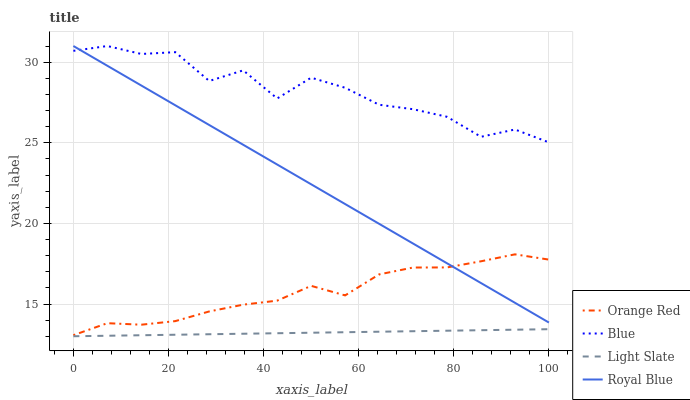Does Orange Red have the minimum area under the curve?
Answer yes or no. No. Does Orange Red have the maximum area under the curve?
Answer yes or no. No. Is Orange Red the smoothest?
Answer yes or no. No. Is Orange Red the roughest?
Answer yes or no. No. Does Orange Red have the lowest value?
Answer yes or no. No. Does Orange Red have the highest value?
Answer yes or no. No. Is Light Slate less than Blue?
Answer yes or no. Yes. Is Orange Red greater than Light Slate?
Answer yes or no. Yes. Does Light Slate intersect Blue?
Answer yes or no. No. 